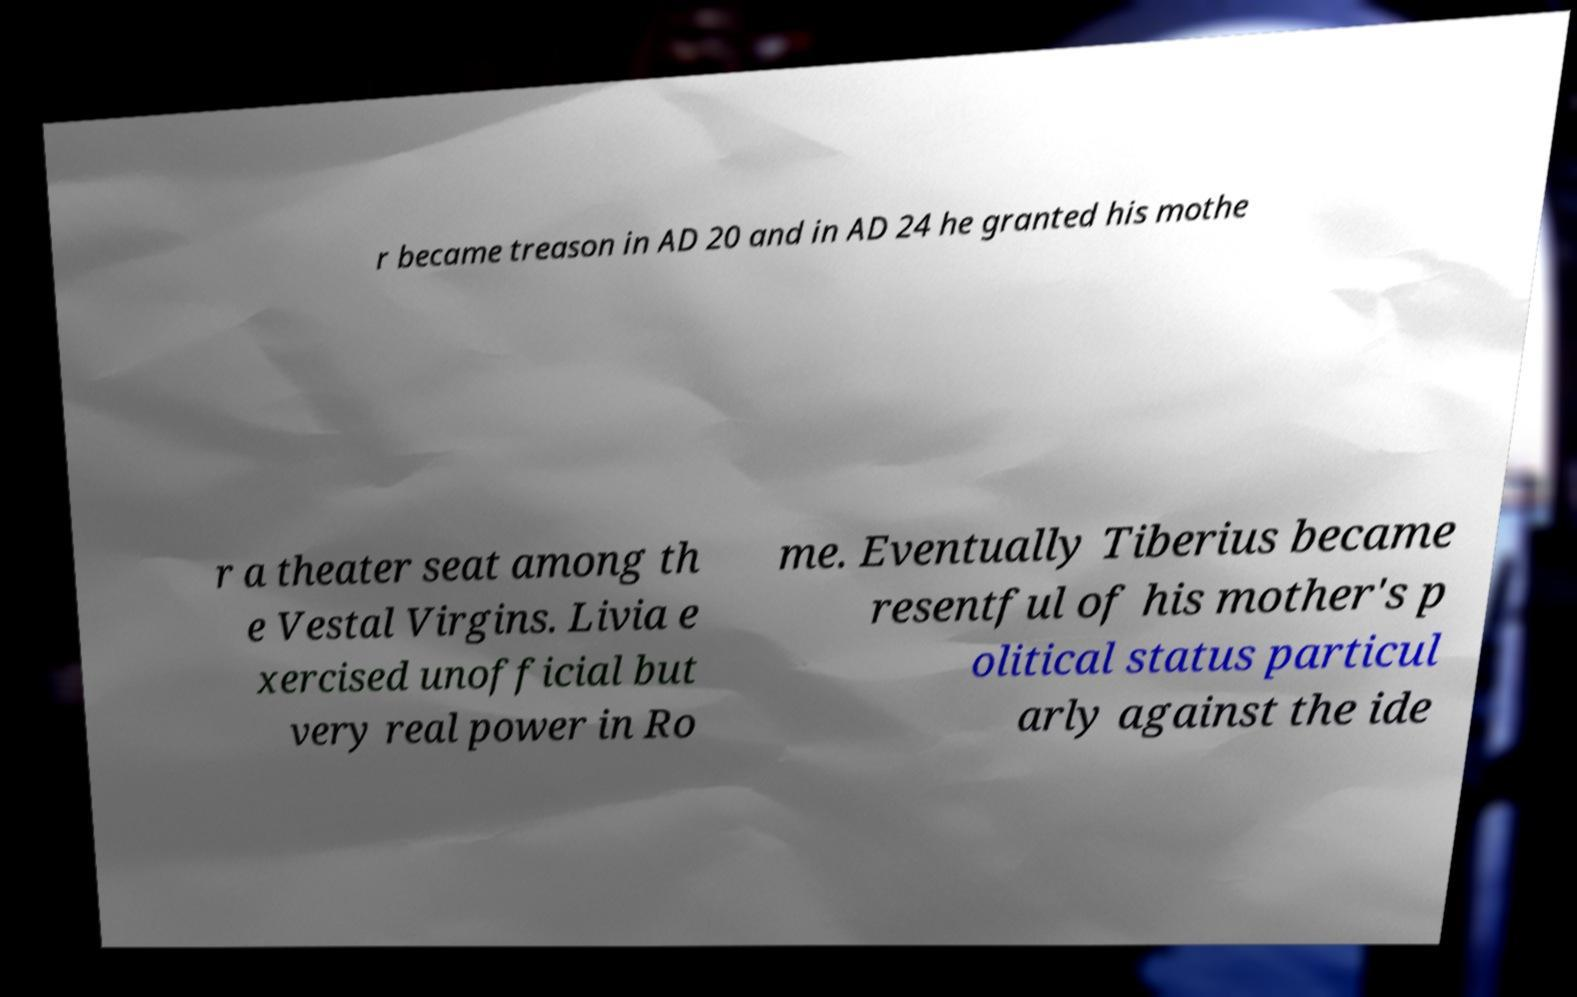Please read and relay the text visible in this image. What does it say? r became treason in AD 20 and in AD 24 he granted his mothe r a theater seat among th e Vestal Virgins. Livia e xercised unofficial but very real power in Ro me. Eventually Tiberius became resentful of his mother's p olitical status particul arly against the ide 